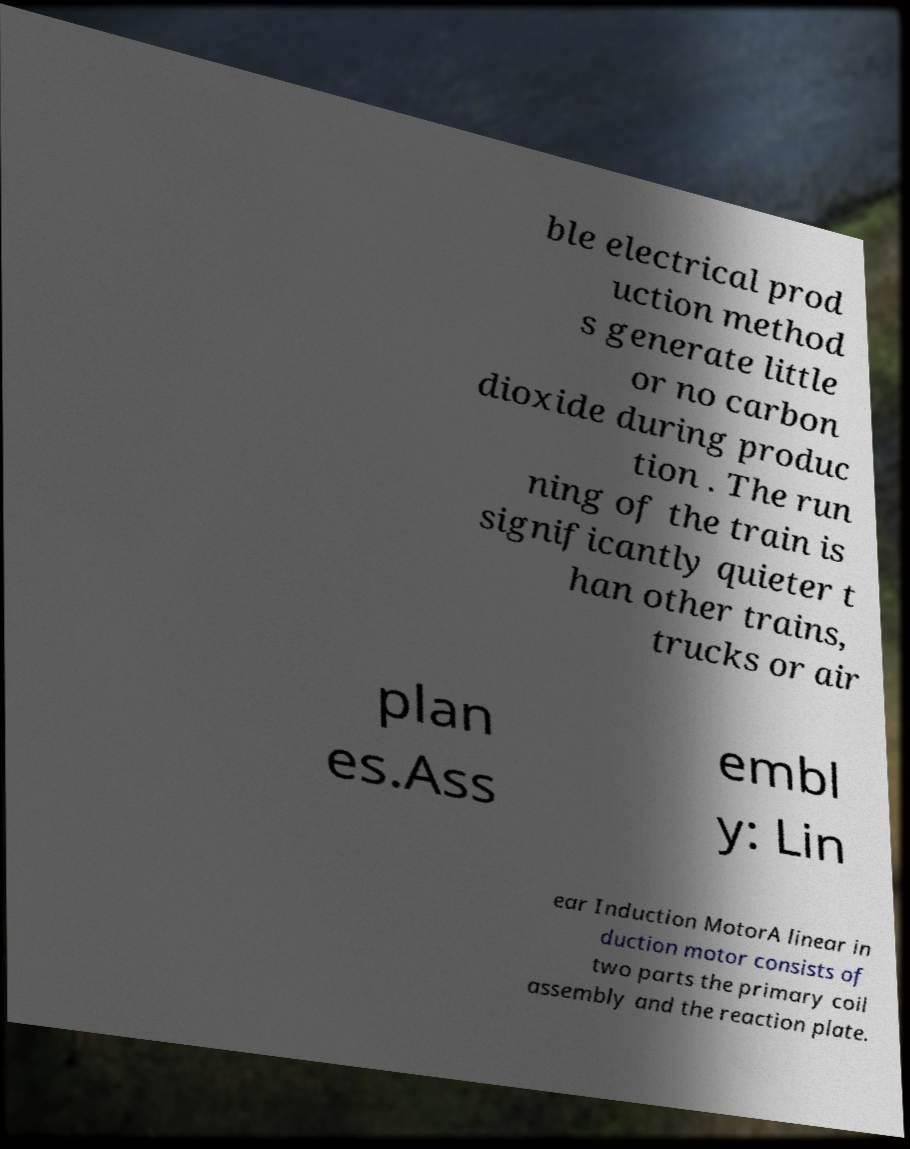What messages or text are displayed in this image? I need them in a readable, typed format. ble electrical prod uction method s generate little or no carbon dioxide during produc tion . The run ning of the train is significantly quieter t han other trains, trucks or air plan es.Ass embl y: Lin ear Induction MotorA linear in duction motor consists of two parts the primary coil assembly and the reaction plate. 